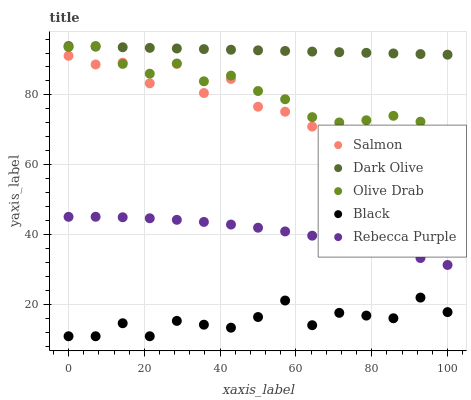Does Black have the minimum area under the curve?
Answer yes or no. Yes. Does Dark Olive have the maximum area under the curve?
Answer yes or no. Yes. Does Salmon have the minimum area under the curve?
Answer yes or no. No. Does Salmon have the maximum area under the curve?
Answer yes or no. No. Is Dark Olive the smoothest?
Answer yes or no. Yes. Is Salmon the roughest?
Answer yes or no. Yes. Is Salmon the smoothest?
Answer yes or no. No. Is Dark Olive the roughest?
Answer yes or no. No. Does Black have the lowest value?
Answer yes or no. Yes. Does Salmon have the lowest value?
Answer yes or no. No. Does Olive Drab have the highest value?
Answer yes or no. Yes. Does Salmon have the highest value?
Answer yes or no. No. Is Rebecca Purple less than Olive Drab?
Answer yes or no. Yes. Is Salmon greater than Rebecca Purple?
Answer yes or no. Yes. Does Salmon intersect Olive Drab?
Answer yes or no. Yes. Is Salmon less than Olive Drab?
Answer yes or no. No. Is Salmon greater than Olive Drab?
Answer yes or no. No. Does Rebecca Purple intersect Olive Drab?
Answer yes or no. No. 